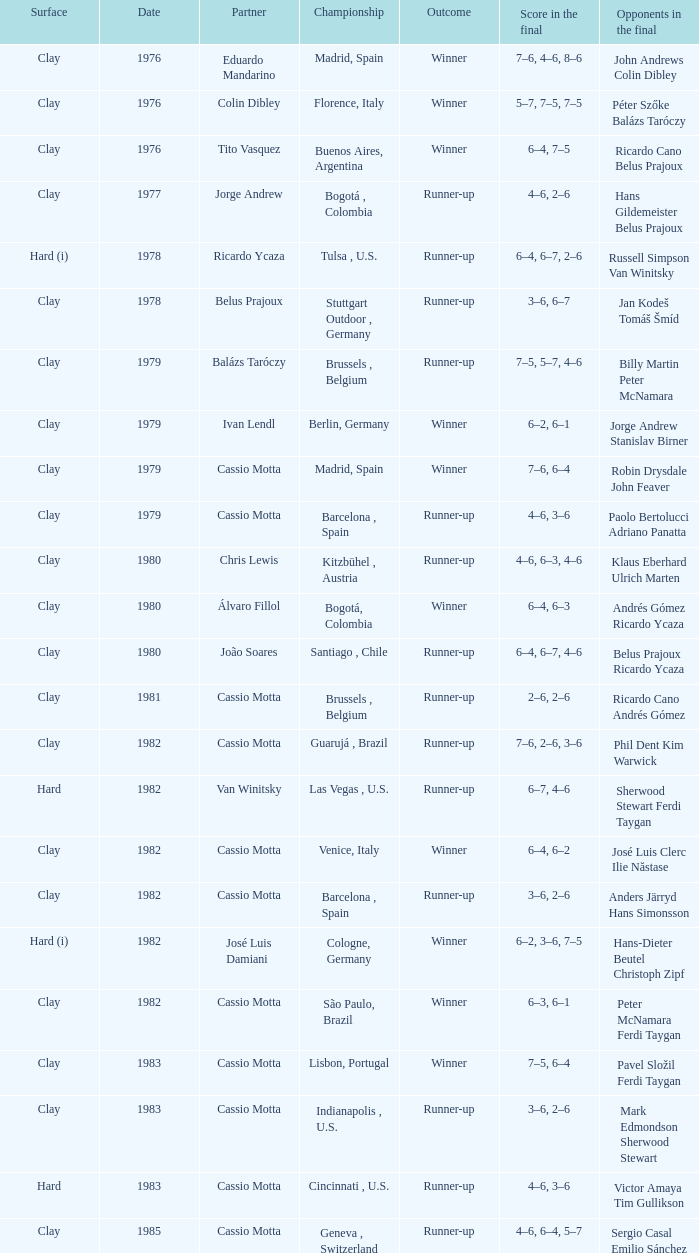What was the surface in 1981? Clay. 